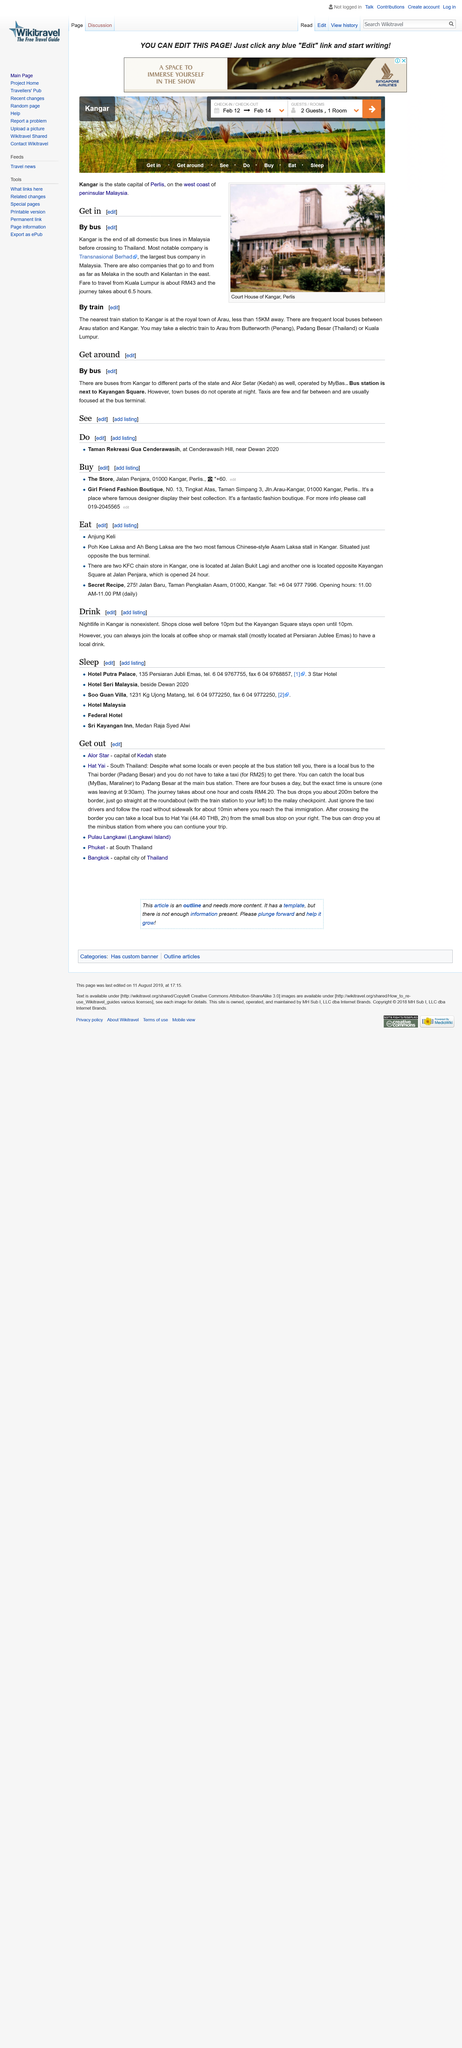Identify some key points in this picture. In Malaysia, all domestic bus lines come to an end at Kagnar before crossing the border into Thailand. The image above depicts the Kangar Court House in Perlis, a courthouse. The most prominent bus company in Malaysia is Transnasional Berhad. 